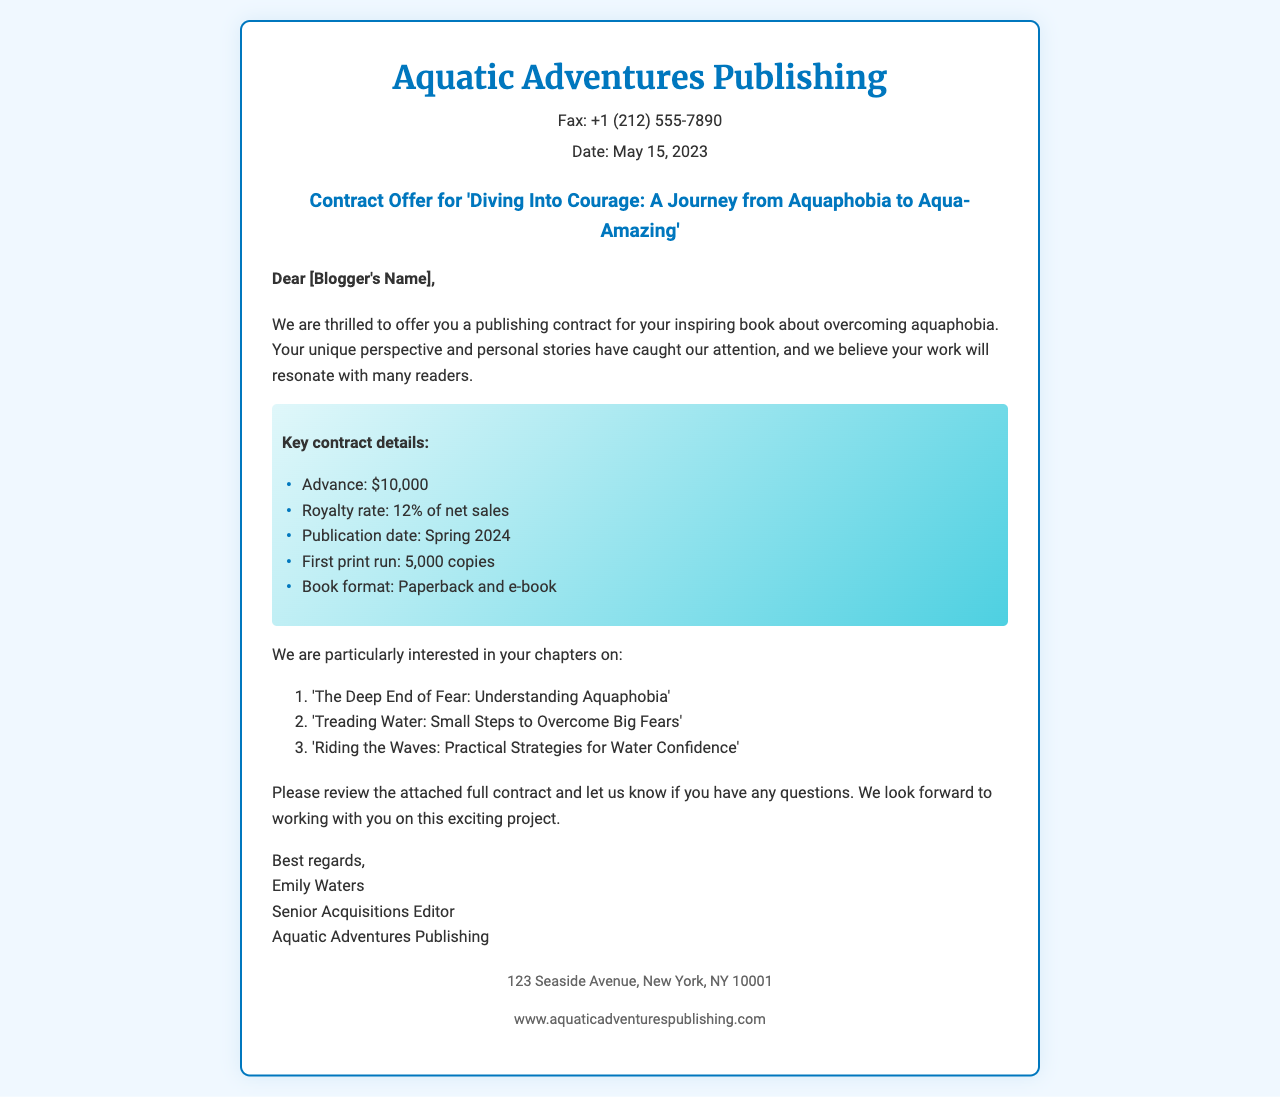What is the name of the publishing house? The publishing house mentioned in the document is Aquatic Adventures Publishing.
Answer: Aquatic Adventures Publishing What is the advance amount offered? The advance amount specified in the contract details is $10,000.
Answer: $10,000 When is the publication date? The document states that the publication date will be in Spring 2024.
Answer: Spring 2024 What is the royalty rate? According to the key contract details, the royalty rate is 12% of net sales.
Answer: 12% of net sales What is the title of the book? The title of the book is 'Diving Into Courage: A Journey from Aquaphobia to Aqua-Amazing'.
Answer: Diving Into Courage: A Journey from Aquaphobia to Aqua-Amazing How many copies will be in the first print run? The first print run is stated to be 5,000 copies.
Answer: 5,000 copies Who is the Senior Acquisitions Editor? The document names Emily Waters as the Senior Acquisitions Editor.
Answer: Emily Waters What chapter focuses on understanding aquaphobia? The chapter focused on understanding aquaphobia is titled 'The Deep End of Fear: Understanding Aquaphobia'.
Answer: The Deep End of Fear: Understanding Aquaphobia What is the format of the book? The book will be available in both paperback and e-book formats.
Answer: Paperback and e-book 